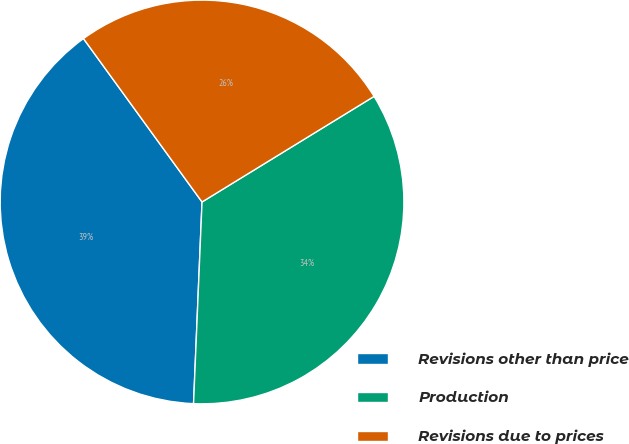Convert chart. <chart><loc_0><loc_0><loc_500><loc_500><pie_chart><fcel>Revisions other than price<fcel>Production<fcel>Revisions due to prices<nl><fcel>39.34%<fcel>34.43%<fcel>26.23%<nl></chart> 